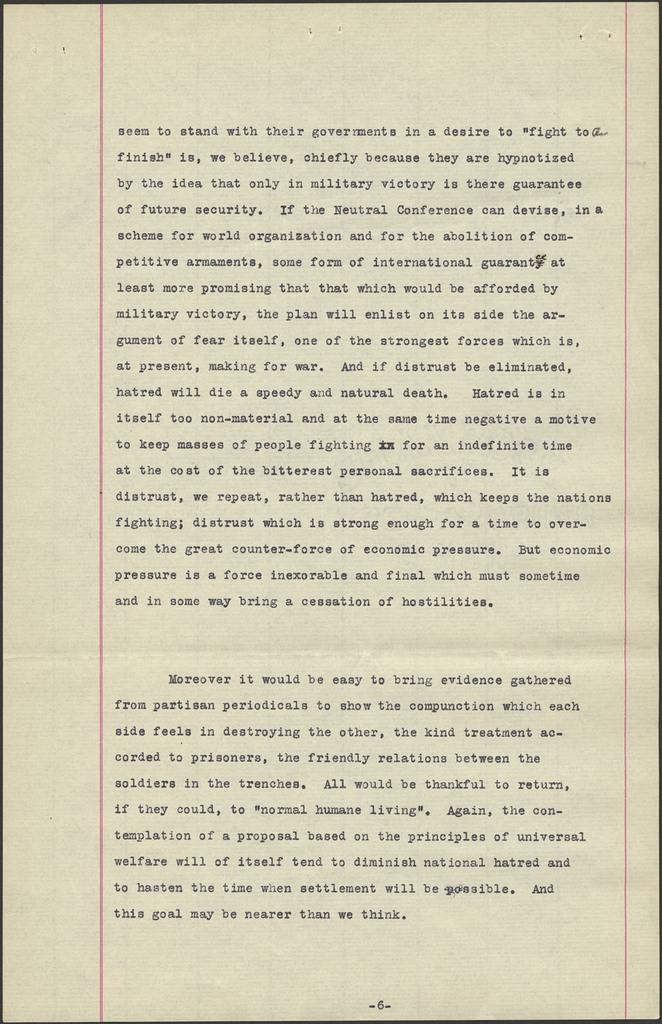<image>
Summarize the visual content of the image. A paper with the staples removed at the top begins with the words "seem to stand with their governments." 